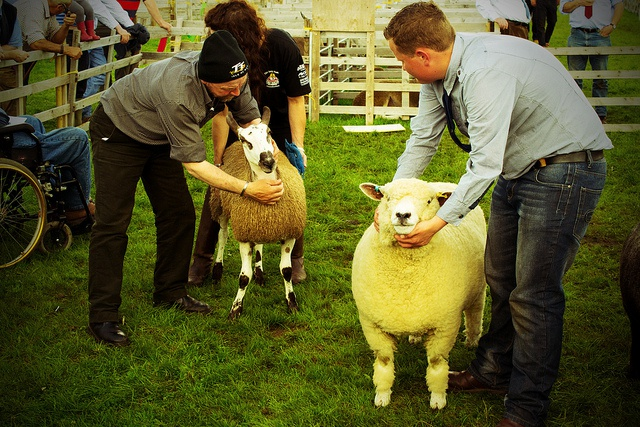Describe the objects in this image and their specific colors. I can see people in black, darkgray, lightgray, and darkgreen tones, people in black, olive, gray, and maroon tones, sheep in black, khaki, olive, and gold tones, sheep in black, olive, and maroon tones, and people in black, maroon, and olive tones in this image. 